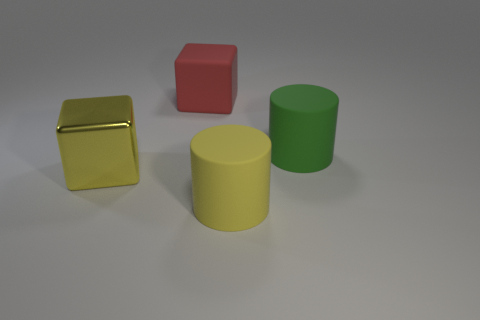What number of yellow objects are either rubber cubes or metallic blocks?
Your answer should be very brief. 1. There is a green object that is the same size as the yellow cylinder; what shape is it?
Your answer should be very brief. Cylinder. How many other objects are the same color as the large matte cube?
Offer a very short reply. 0. What is the size of the block that is left of the red thing on the right side of the yellow shiny object?
Give a very brief answer. Large. Does the cylinder that is behind the yellow cylinder have the same material as the big yellow block?
Give a very brief answer. No. What shape is the object left of the big red object?
Provide a short and direct response. Cube. How many green rubber things have the same size as the green cylinder?
Provide a succinct answer. 0. There is a yellow metallic block; what number of big cubes are right of it?
Your answer should be compact. 1. The large green thing that is the same material as the big yellow cylinder is what shape?
Ensure brevity in your answer.  Cylinder. Is the number of yellow things on the right side of the big yellow matte thing less than the number of yellow rubber things that are to the left of the rubber cube?
Your response must be concise. No. 